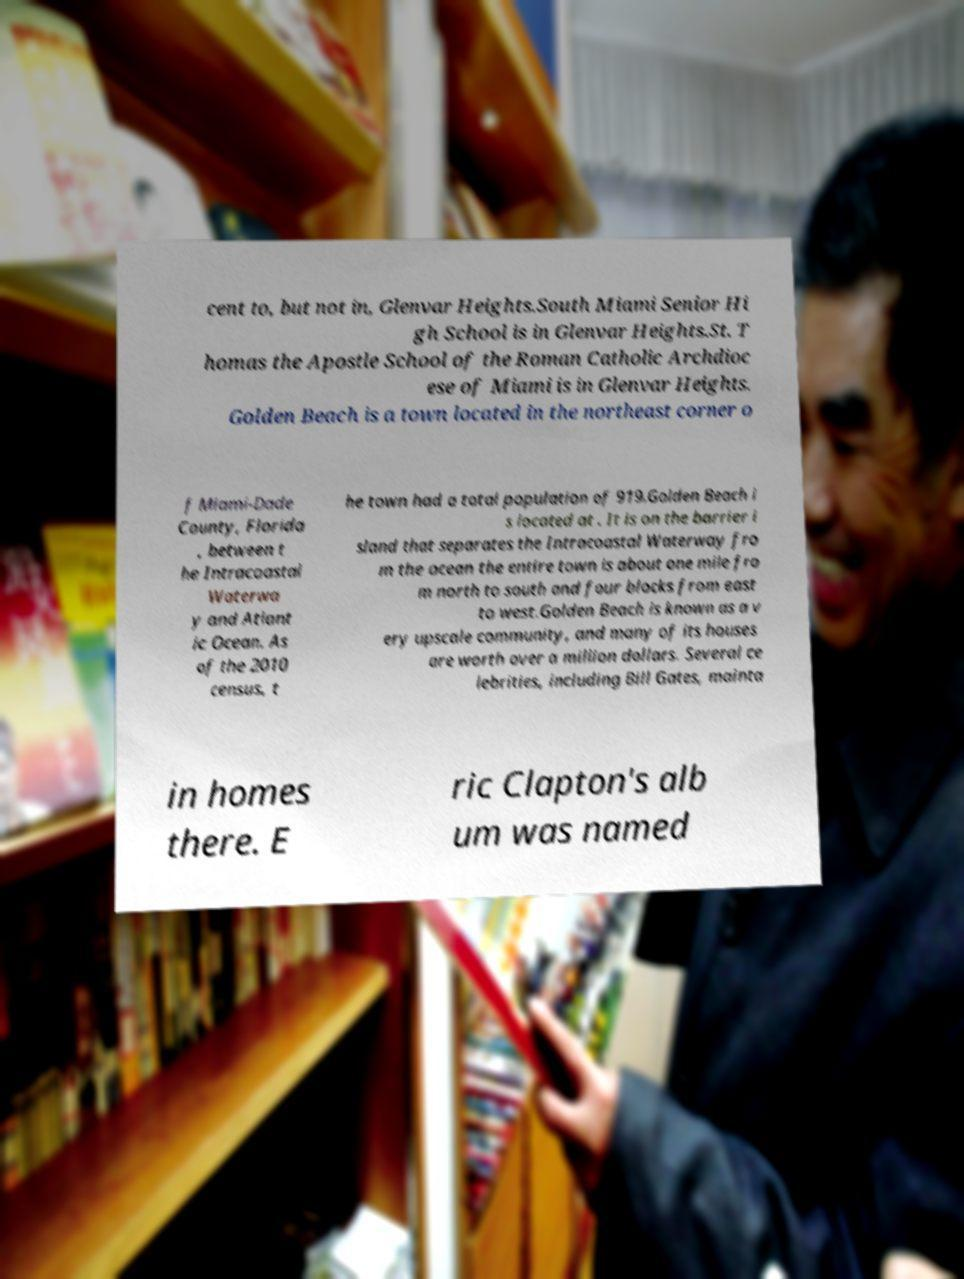Please identify and transcribe the text found in this image. cent to, but not in, Glenvar Heights.South Miami Senior Hi gh School is in Glenvar Heights.St. T homas the Apostle School of the Roman Catholic Archdioc ese of Miami is in Glenvar Heights. Golden Beach is a town located in the northeast corner o f Miami-Dade County, Florida , between t he Intracoastal Waterwa y and Atlant ic Ocean. As of the 2010 census, t he town had a total population of 919.Golden Beach i s located at . It is on the barrier i sland that separates the Intracoastal Waterway fro m the ocean the entire town is about one mile fro m north to south and four blocks from east to west.Golden Beach is known as a v ery upscale community, and many of its houses are worth over a million dollars. Several ce lebrities, including Bill Gates, mainta in homes there. E ric Clapton's alb um was named 